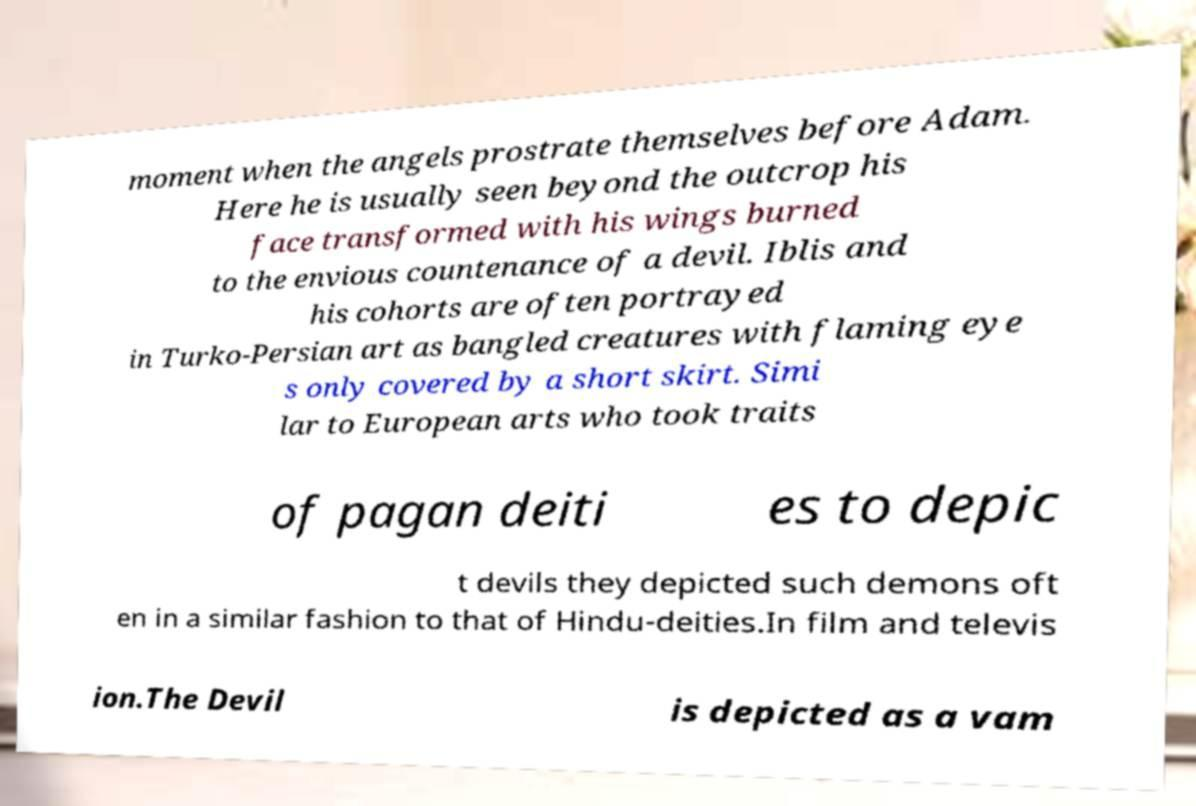Please identify and transcribe the text found in this image. moment when the angels prostrate themselves before Adam. Here he is usually seen beyond the outcrop his face transformed with his wings burned to the envious countenance of a devil. Iblis and his cohorts are often portrayed in Turko-Persian art as bangled creatures with flaming eye s only covered by a short skirt. Simi lar to European arts who took traits of pagan deiti es to depic t devils they depicted such demons oft en in a similar fashion to that of Hindu-deities.In film and televis ion.The Devil is depicted as a vam 